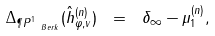Convert formula to latex. <formula><loc_0><loc_0><loc_500><loc_500>\Delta _ { \P P ^ { 1 } _ { \ B e r k } } ( \hat { h } ^ { ( n ) } _ { \varphi , v } ) \ = \ \delta _ { \infty } - \mu _ { 1 } ^ { ( n ) } ,</formula> 